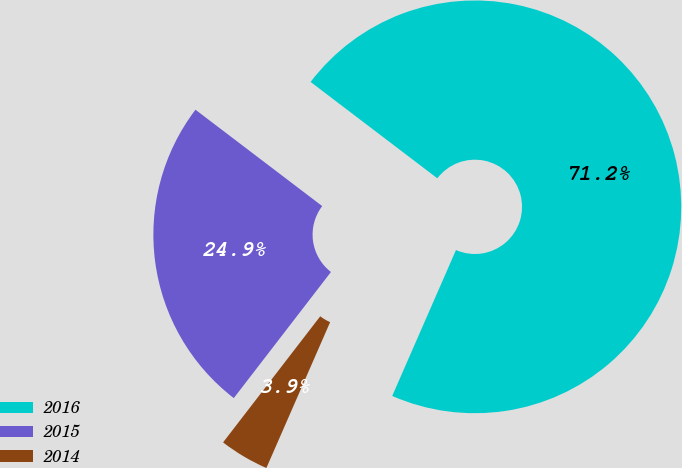Convert chart. <chart><loc_0><loc_0><loc_500><loc_500><pie_chart><fcel>2016<fcel>2015<fcel>2014<nl><fcel>71.21%<fcel>24.9%<fcel>3.89%<nl></chart> 